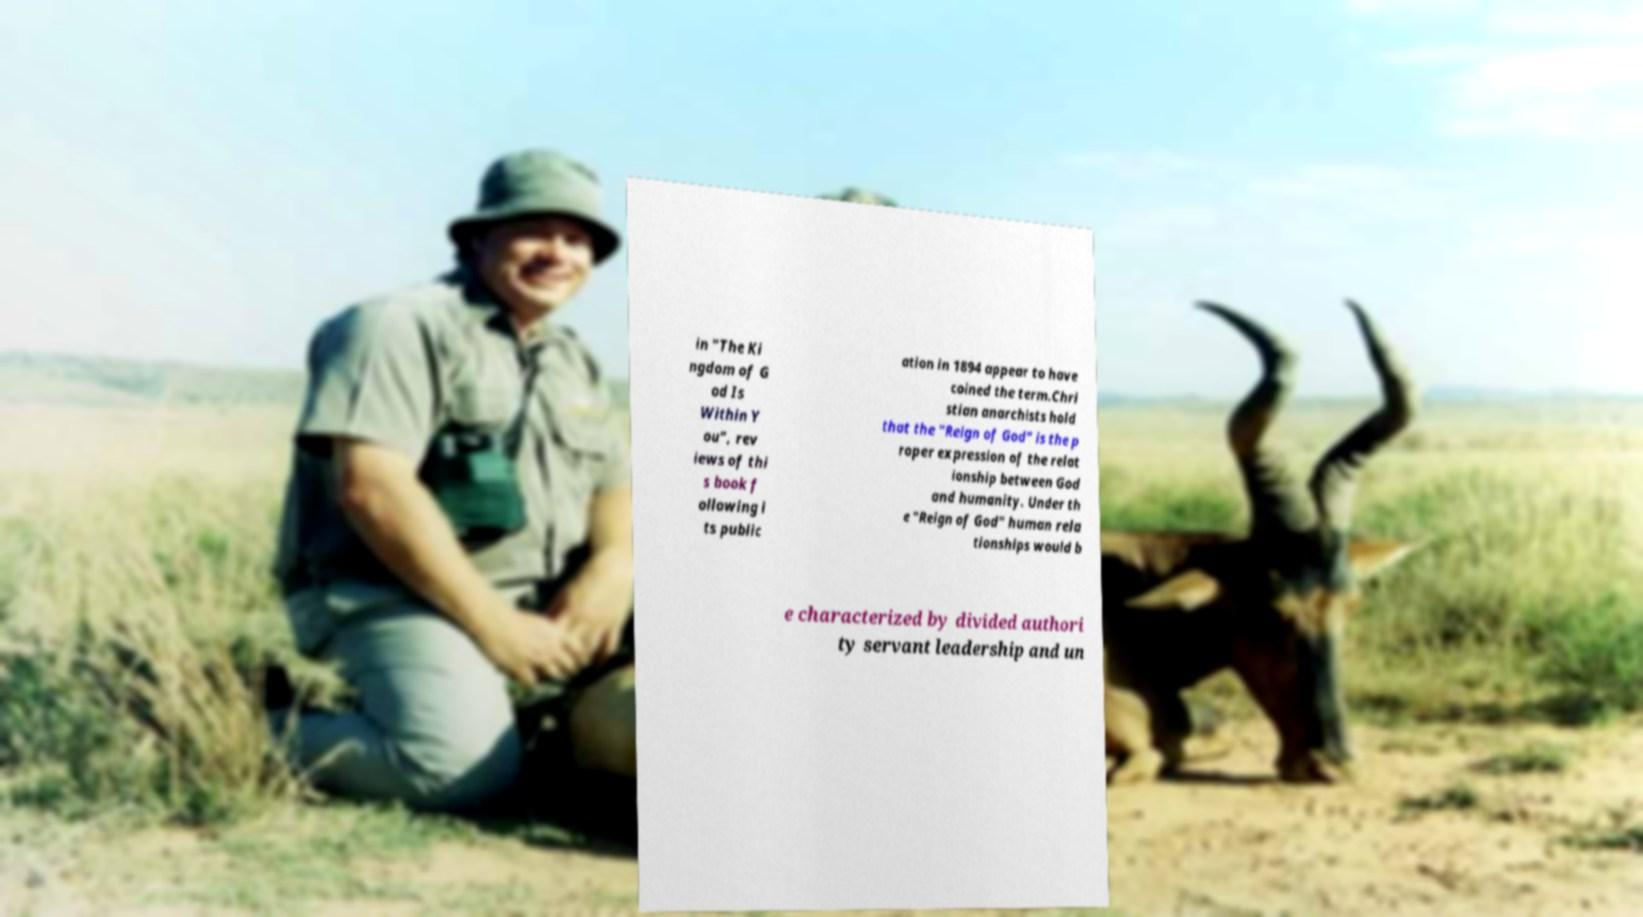Please read and relay the text visible in this image. What does it say? in "The Ki ngdom of G od Is Within Y ou", rev iews of thi s book f ollowing i ts public ation in 1894 appear to have coined the term.Chri stian anarchists hold that the "Reign of God" is the p roper expression of the relat ionship between God and humanity. Under th e "Reign of God" human rela tionships would b e characterized by divided authori ty servant leadership and un 